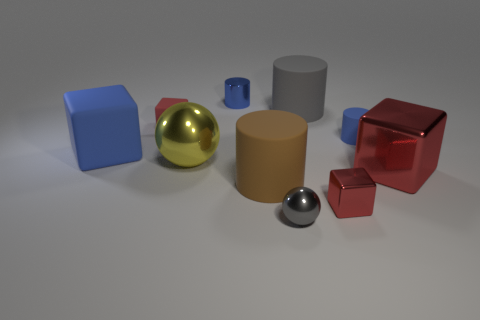How many red cubes must be subtracted to get 1 red cubes? 2 Subtract all gray spheres. How many red cubes are left? 3 Subtract 1 cylinders. How many cylinders are left? 3 Subtract all blue cubes. How many cubes are left? 3 Subtract all big gray rubber cylinders. How many cylinders are left? 3 Subtract all red cylinders. Subtract all red spheres. How many cylinders are left? 4 Subtract all cubes. How many objects are left? 6 Subtract all small cyan metallic spheres. Subtract all tiny objects. How many objects are left? 5 Add 1 brown rubber things. How many brown rubber things are left? 2 Add 4 big blue cylinders. How many big blue cylinders exist? 4 